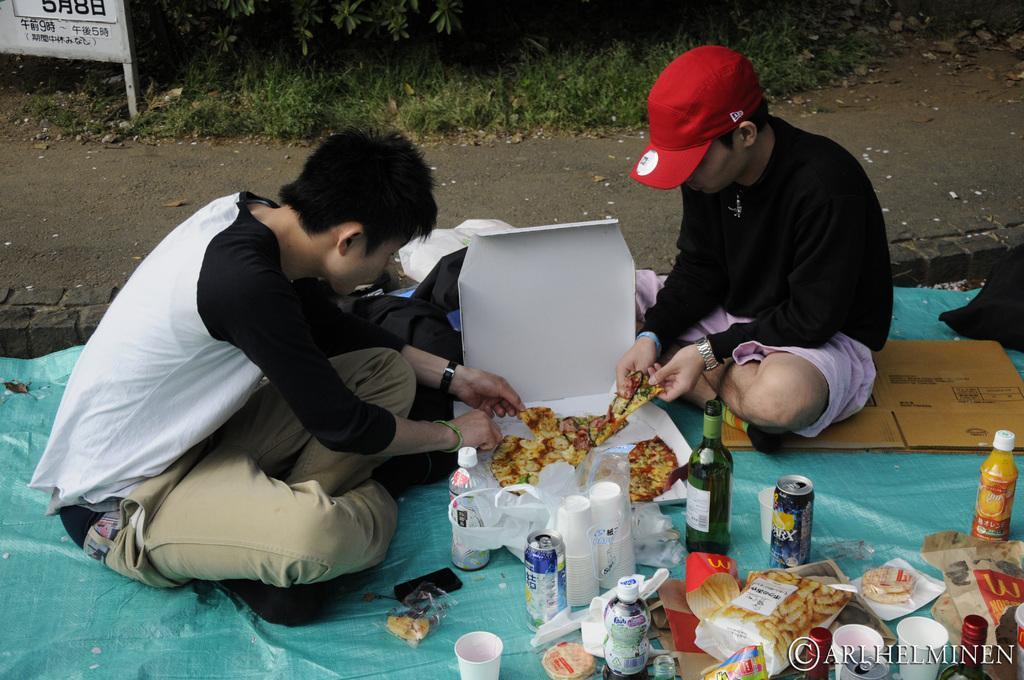Can you describe this image briefly? There are two men sitting in the middle of this image. The person on the right side of this image is holding a piece of a pizza. We can food items, bottles, glasses are kept at the bottom of this image. There are plants, grass and a board at the top of this image. 